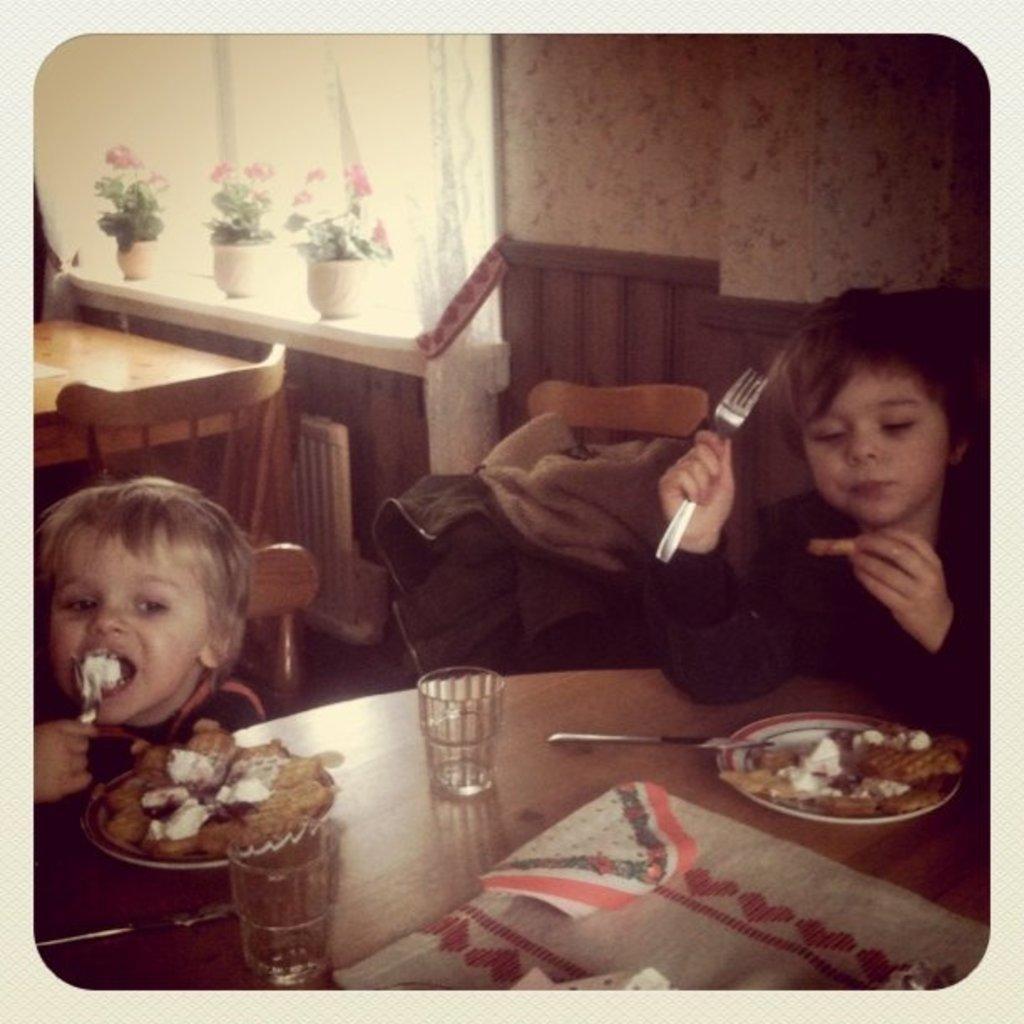How would you summarize this image in a sentence or two? In this image we can see a photo with the border and we can see two children sitting and it looks like they are eating. We can see a table with food items, glasses and some other objects and we can see some other things in the room and there are some potted plants in the background. 